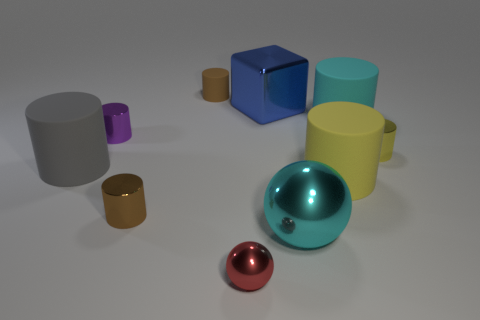Is the material of the block the same as the purple cylinder?
Your answer should be compact. Yes. What shape is the large object on the left side of the tiny purple metallic cylinder that is on the left side of the shiny cylinder to the right of the brown rubber cylinder?
Provide a short and direct response. Cylinder. What is the material of the large object that is both on the right side of the cyan sphere and behind the gray rubber thing?
Your answer should be compact. Rubber. There is a small shiny object that is in front of the brown thing in front of the tiny thing to the left of the brown metallic object; what color is it?
Ensure brevity in your answer.  Red. How many blue objects are blocks or large spheres?
Offer a very short reply. 1. How many other things are the same size as the brown metallic cylinder?
Ensure brevity in your answer.  4. What number of cyan metallic cubes are there?
Give a very brief answer. 0. Is there anything else that is the same shape as the big blue thing?
Your response must be concise. No. Is the material of the tiny brown cylinder that is in front of the blue metal object the same as the thing right of the cyan matte cylinder?
Give a very brief answer. Yes. What is the material of the large yellow cylinder?
Your response must be concise. Rubber. 